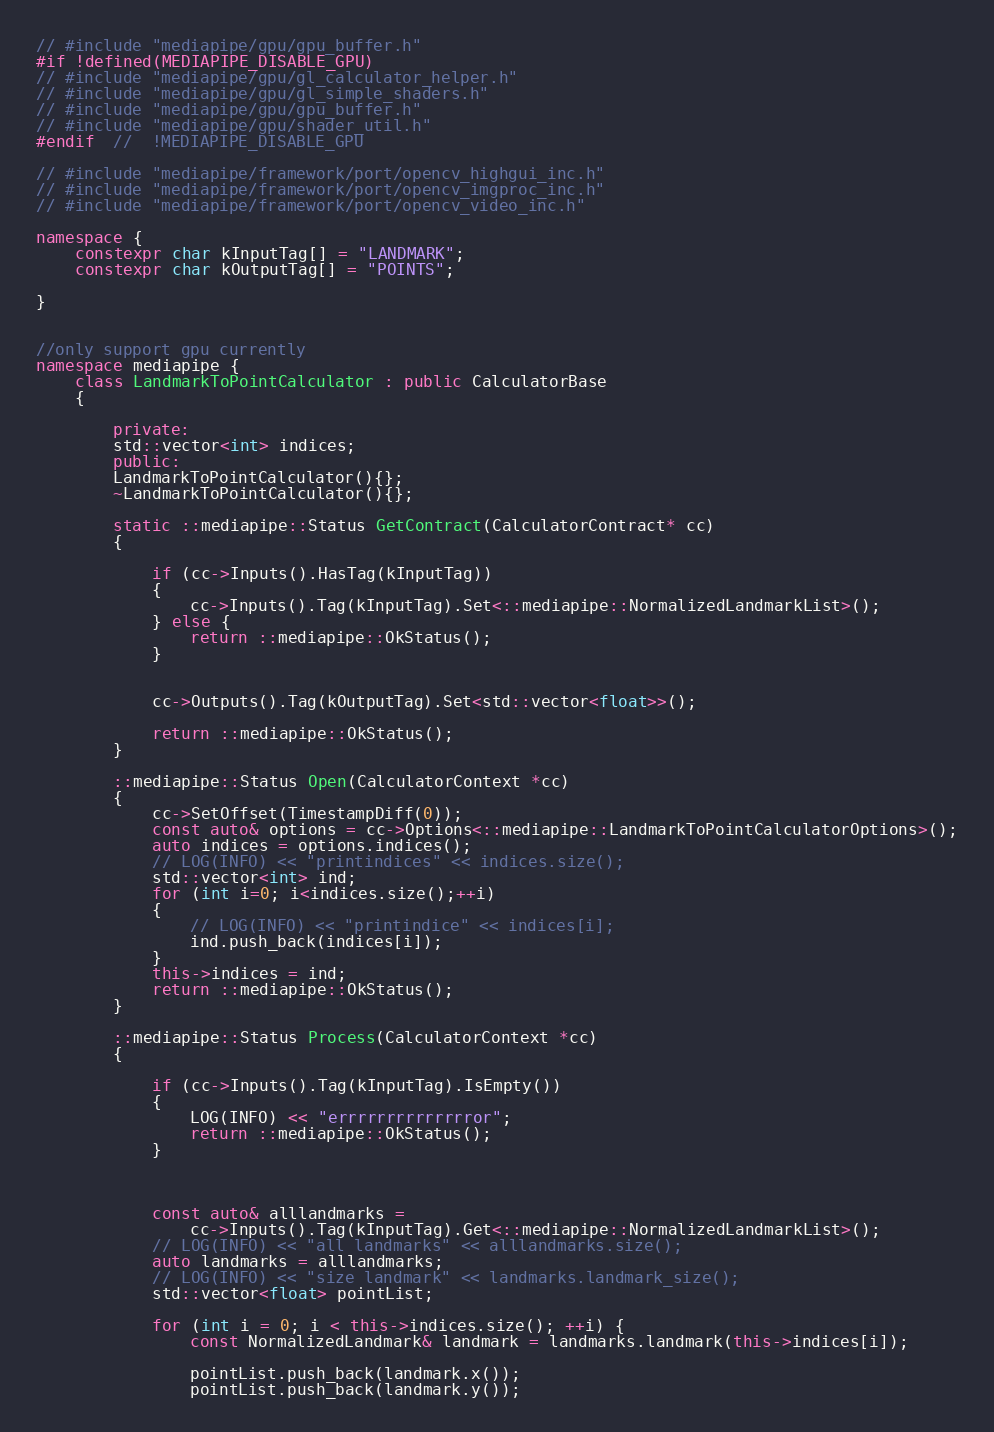<code> <loc_0><loc_0><loc_500><loc_500><_C++_>// #include "mediapipe/gpu/gpu_buffer.h"
#if !defined(MEDIAPIPE_DISABLE_GPU)
// #include "mediapipe/gpu/gl_calculator_helper.h"
// #include "mediapipe/gpu/gl_simple_shaders.h"
// #include "mediapipe/gpu/gpu_buffer.h"
// #include "mediapipe/gpu/shader_util.h"
#endif  //  !MEDIAPIPE_DISABLE_GPU

// #include "mediapipe/framework/port/opencv_highgui_inc.h"
// #include "mediapipe/framework/port/opencv_imgproc_inc.h"
// #include "mediapipe/framework/port/opencv_video_inc.h"

namespace {
    constexpr char kInputTag[] = "LANDMARK";
    constexpr char kOutputTag[] = "POINTS";

}


//only support gpu currently
namespace mediapipe {
    class LandmarkToPointCalculator : public CalculatorBase
    {   

        private:
        std::vector<int> indices;
        public:
        LandmarkToPointCalculator(){};
        ~LandmarkToPointCalculator(){};

        static ::mediapipe::Status GetContract(CalculatorContract* cc)
        {

            if (cc->Inputs().HasTag(kInputTag))
            {
                cc->Inputs().Tag(kInputTag).Set<::mediapipe::NormalizedLandmarkList>();
            } else {
                return ::mediapipe::OkStatus();
            }
            

            cc->Outputs().Tag(kOutputTag).Set<std::vector<float>>();

            return ::mediapipe::OkStatus();
        }

        ::mediapipe::Status Open(CalculatorContext *cc)
        {
            cc->SetOffset(TimestampDiff(0));
            const auto& options = cc->Options<::mediapipe::LandmarkToPointCalculatorOptions>();
            auto indices = options.indices();
            // LOG(INFO) << "printindices" << indices.size();
            std::vector<int> ind;
            for (int i=0; i<indices.size();++i)
            {
                // LOG(INFO) << "printindice" << indices[i];
                ind.push_back(indices[i]);
            }
            this->indices = ind;
            return ::mediapipe::OkStatus();
        }

        ::mediapipe::Status Process(CalculatorContext *cc)
        {

            if (cc->Inputs().Tag(kInputTag).IsEmpty())
            {
                LOG(INFO) << "errrrrrrrrrrrrror";
                return ::mediapipe::OkStatus();
            } 
            

            
            const auto& alllandmarks = 
                cc->Inputs().Tag(kInputTag).Get<::mediapipe::NormalizedLandmarkList>();
            // LOG(INFO) << "all landmarks" << alllandmarks.size();
            auto landmarks = alllandmarks;
            // LOG(INFO) << "size landmark" << landmarks.landmark_size();
            std::vector<float> pointList;
                
            for (int i = 0; i < this->indices.size(); ++i) {
                const NormalizedLandmark& landmark = landmarks.landmark(this->indices[i]);
                
                pointList.push_back(landmark.x());
                pointList.push_back(landmark.y());</code> 